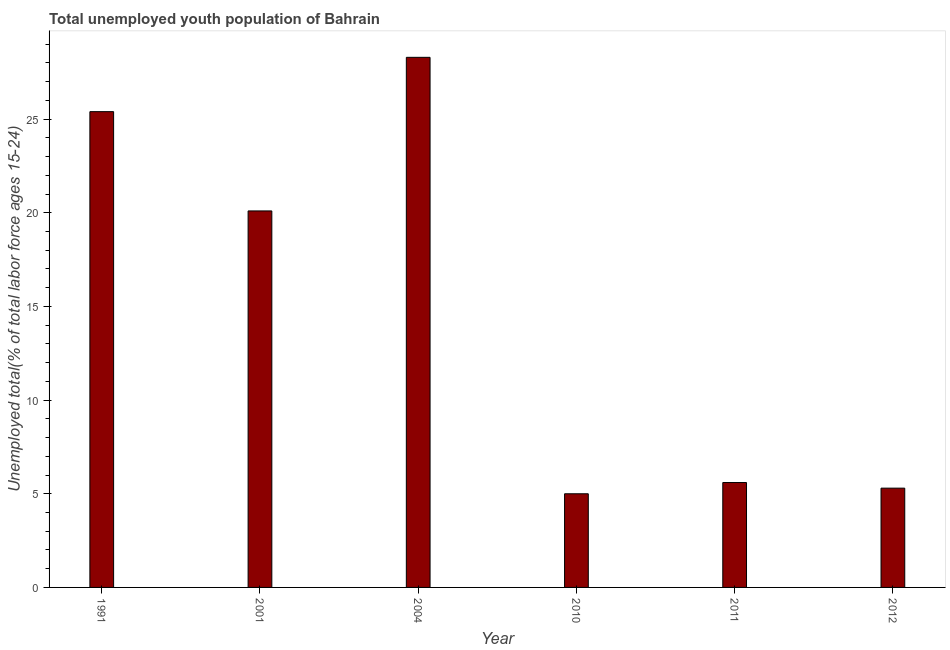Does the graph contain grids?
Your answer should be very brief. No. What is the title of the graph?
Provide a succinct answer. Total unemployed youth population of Bahrain. What is the label or title of the X-axis?
Your answer should be very brief. Year. What is the label or title of the Y-axis?
Make the answer very short. Unemployed total(% of total labor force ages 15-24). Across all years, what is the maximum unemployed youth?
Keep it short and to the point. 28.3. In which year was the unemployed youth maximum?
Your answer should be compact. 2004. What is the sum of the unemployed youth?
Your response must be concise. 89.7. What is the average unemployed youth per year?
Offer a very short reply. 14.95. What is the median unemployed youth?
Give a very brief answer. 12.85. What is the ratio of the unemployed youth in 1991 to that in 2001?
Provide a short and direct response. 1.26. Is the unemployed youth in 1991 less than that in 2012?
Keep it short and to the point. No. What is the difference between the highest and the lowest unemployed youth?
Offer a very short reply. 23.3. In how many years, is the unemployed youth greater than the average unemployed youth taken over all years?
Offer a terse response. 3. How many bars are there?
Offer a very short reply. 6. Are all the bars in the graph horizontal?
Provide a short and direct response. No. What is the Unemployed total(% of total labor force ages 15-24) of 1991?
Provide a short and direct response. 25.4. What is the Unemployed total(% of total labor force ages 15-24) of 2001?
Provide a short and direct response. 20.1. What is the Unemployed total(% of total labor force ages 15-24) of 2004?
Give a very brief answer. 28.3. What is the Unemployed total(% of total labor force ages 15-24) in 2011?
Ensure brevity in your answer.  5.6. What is the Unemployed total(% of total labor force ages 15-24) in 2012?
Your answer should be compact. 5.3. What is the difference between the Unemployed total(% of total labor force ages 15-24) in 1991 and 2004?
Ensure brevity in your answer.  -2.9. What is the difference between the Unemployed total(% of total labor force ages 15-24) in 1991 and 2010?
Provide a succinct answer. 20.4. What is the difference between the Unemployed total(% of total labor force ages 15-24) in 1991 and 2011?
Keep it short and to the point. 19.8. What is the difference between the Unemployed total(% of total labor force ages 15-24) in 1991 and 2012?
Keep it short and to the point. 20.1. What is the difference between the Unemployed total(% of total labor force ages 15-24) in 2001 and 2010?
Your answer should be very brief. 15.1. What is the difference between the Unemployed total(% of total labor force ages 15-24) in 2004 and 2010?
Your answer should be compact. 23.3. What is the difference between the Unemployed total(% of total labor force ages 15-24) in 2004 and 2011?
Make the answer very short. 22.7. What is the difference between the Unemployed total(% of total labor force ages 15-24) in 2010 and 2012?
Offer a very short reply. -0.3. What is the difference between the Unemployed total(% of total labor force ages 15-24) in 2011 and 2012?
Make the answer very short. 0.3. What is the ratio of the Unemployed total(% of total labor force ages 15-24) in 1991 to that in 2001?
Make the answer very short. 1.26. What is the ratio of the Unemployed total(% of total labor force ages 15-24) in 1991 to that in 2004?
Your response must be concise. 0.9. What is the ratio of the Unemployed total(% of total labor force ages 15-24) in 1991 to that in 2010?
Keep it short and to the point. 5.08. What is the ratio of the Unemployed total(% of total labor force ages 15-24) in 1991 to that in 2011?
Provide a short and direct response. 4.54. What is the ratio of the Unemployed total(% of total labor force ages 15-24) in 1991 to that in 2012?
Provide a short and direct response. 4.79. What is the ratio of the Unemployed total(% of total labor force ages 15-24) in 2001 to that in 2004?
Offer a terse response. 0.71. What is the ratio of the Unemployed total(% of total labor force ages 15-24) in 2001 to that in 2010?
Keep it short and to the point. 4.02. What is the ratio of the Unemployed total(% of total labor force ages 15-24) in 2001 to that in 2011?
Your answer should be very brief. 3.59. What is the ratio of the Unemployed total(% of total labor force ages 15-24) in 2001 to that in 2012?
Your answer should be compact. 3.79. What is the ratio of the Unemployed total(% of total labor force ages 15-24) in 2004 to that in 2010?
Keep it short and to the point. 5.66. What is the ratio of the Unemployed total(% of total labor force ages 15-24) in 2004 to that in 2011?
Offer a terse response. 5.05. What is the ratio of the Unemployed total(% of total labor force ages 15-24) in 2004 to that in 2012?
Your response must be concise. 5.34. What is the ratio of the Unemployed total(% of total labor force ages 15-24) in 2010 to that in 2011?
Offer a very short reply. 0.89. What is the ratio of the Unemployed total(% of total labor force ages 15-24) in 2010 to that in 2012?
Offer a very short reply. 0.94. What is the ratio of the Unemployed total(% of total labor force ages 15-24) in 2011 to that in 2012?
Your response must be concise. 1.06. 